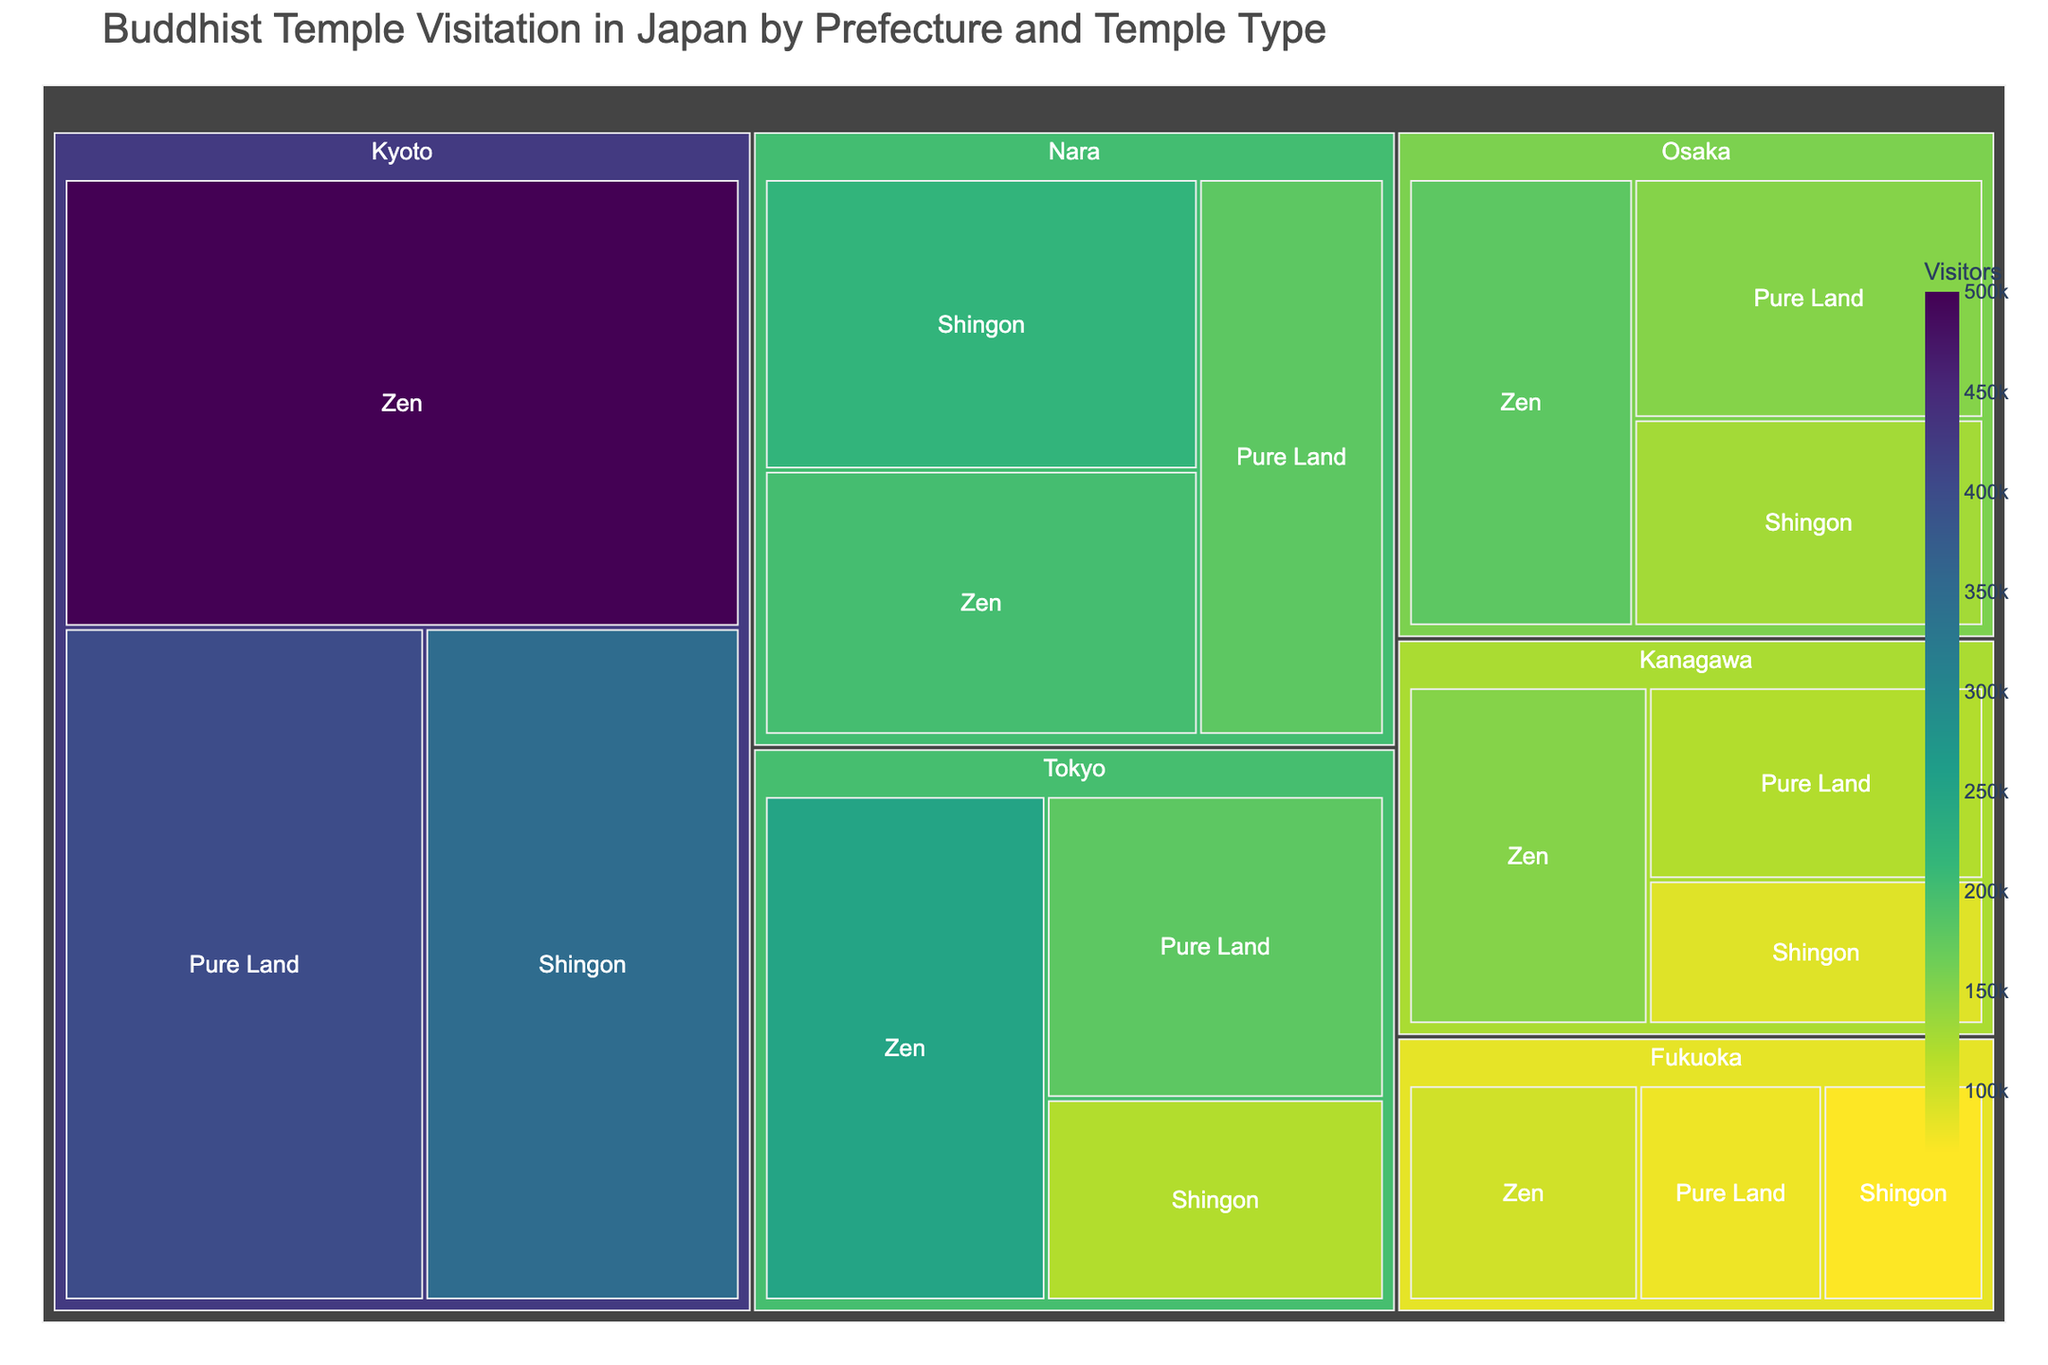What's the title of the figure? The title of the figure is displayed at the top of the treemap.
Answer: Buddhist Temple Visitation in Japan by Prefecture and Temple Type Which prefecture has the highest number of visitors to Zen temples? By observing the largest segment for Zen temples, you can determine which prefecture has the highest number of visitors. Look for the segment labeled "Zen" with the largest area.
Answer: Kyoto How many total visitors are there to temples in Tokyo? You need to sum the number of visitors to Zen, Pure Land, and Shingon temples in Tokyo. The values are shown in the corresponding segments.
Answer: 550,000 Compare the number of visitors to Zen temples in Tokyo and Osaka. Which prefecture has more, and by how much? Identify the visitors to Zen temples in both Tokyo and Osaka. Tokyo has 250,000 visitors, while Osaka has 180,000. The difference is 250,000 - 180,000.
Answer: Tokyo by 70,000 What is the ratio of visitors to Shingon temples in Nara compared to Fukuoka? Find the number of visitors to Shingon temples in Nara and Fukuoka. Nara has 220,000 visitors and Fukuoka has 70,000 visitors. Divide the former by the latter.
Answer: 3.14 (rounded to 2 decimal places) Which temple type in Kyoto attracts the least number of visitors? Look at the segments for each temple type in Kyoto and identify the one with the smallest area/number of visitors.
Answer: Shingon What is the percentage of visitors to Pure Land temples in Kanagawa out of the total visitors to Kanagawa? Calculate the total number of visitors to Kanagawa (150,000 + 120,000 + 90,000 = 360,000). Then find the percentage of Pure Land visitors (120,000/360,000 * 100).
Answer: 33.33% How do the total visitor numbers to temples in Nara compare to those in Fukuoka? Sum the visitor numbers for all temple types in Nara and Fukuoka. Nara has 600,000 visitors and Fukuoka has 250,000 visitors. Compare the sums.
Answer: Nara has 350,000 more visitors Identify the prefecture with the least visitors to Pure Land temples and state the number of visitors. Find the segment labeled "Pure Land" with the smallest area.
Answer: Fukuoka, 80,000 What is the combined number of visitors to Zen temples across all prefectures? Sum the visitors to Zen temples in all prefectures: 250,000 (Tokyo) + 500,000 (Kyoto) + 200,000 (Nara) + 150,000 (Kanagawa) + 180,000 (Osaka) + 100,000 (Fukuoka).
Answer: 1,380,000 